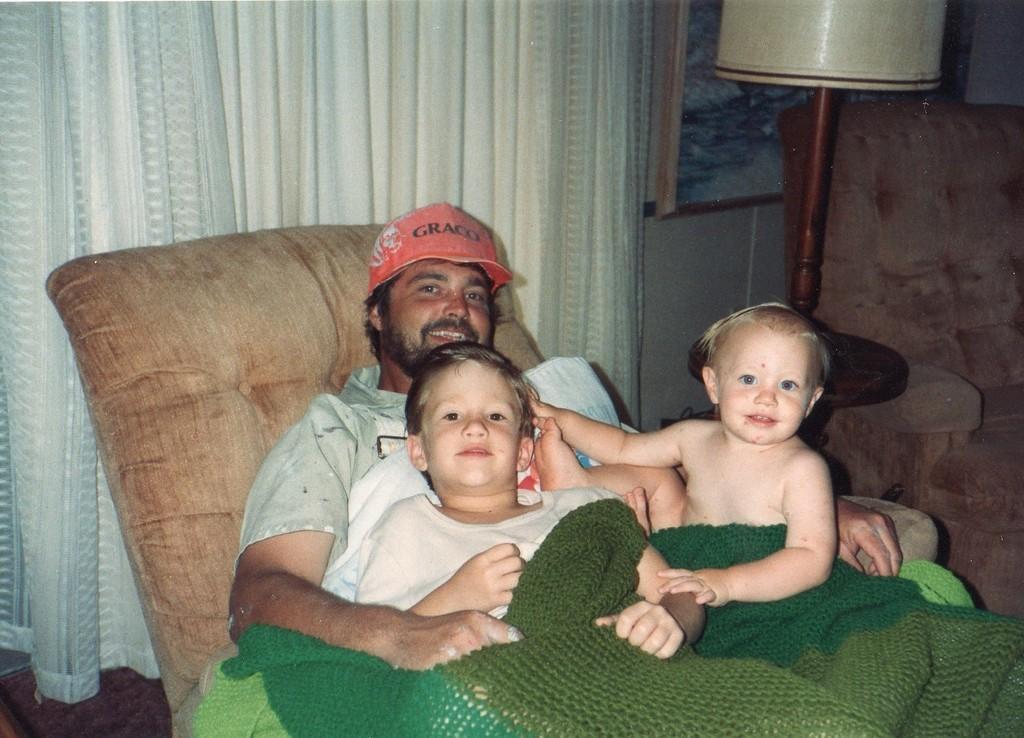How would you summarize this image in a sentence or two? In this image we can see a sofa chair. In the back there is a person wearing cap is sitting. With him there are two children. Near to him there is a table lamp. In the back there are curtains. And a wall with a photo frame. 